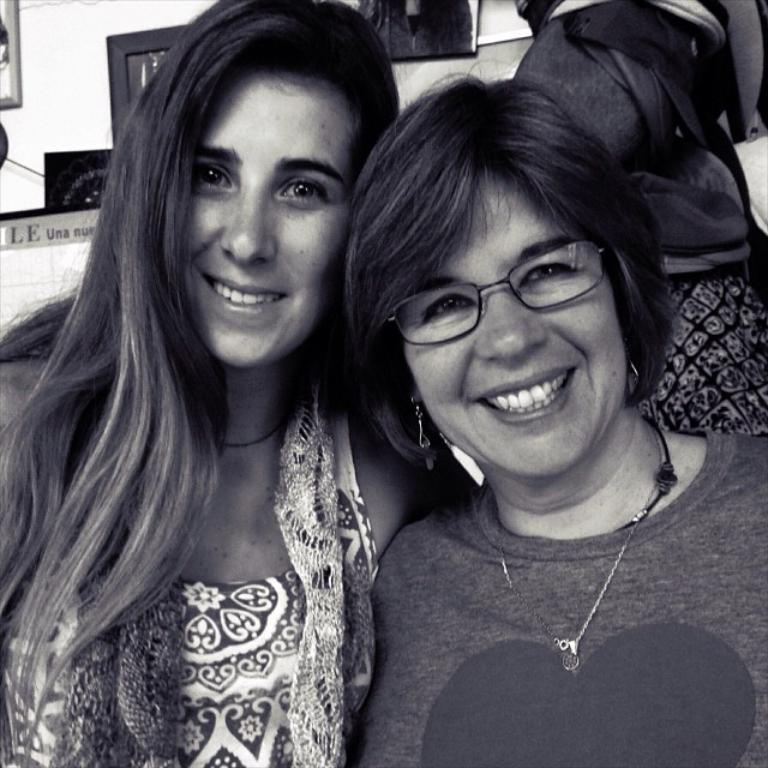How many people are in the image? There are two women in the image. What are the expressions on their faces? The women are smiling in the image. What can be seen in the background of the image? There is a bag, frames on a wall, and other objects in the background of the image. What type of coast can be seen in the background of the image? There is no coast visible in the image; it is an indoor setting with a bag, frames on a wall, and other objects in the background. 